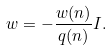Convert formula to latex. <formula><loc_0><loc_0><loc_500><loc_500>w = - \frac { w ( n ) } { q ( n ) } I .</formula> 